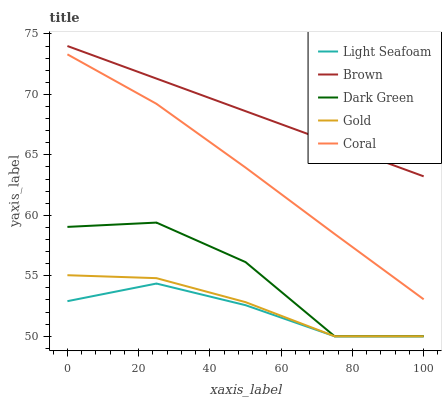Does Light Seafoam have the minimum area under the curve?
Answer yes or no. Yes. Does Brown have the maximum area under the curve?
Answer yes or no. Yes. Does Coral have the minimum area under the curve?
Answer yes or no. No. Does Coral have the maximum area under the curve?
Answer yes or no. No. Is Brown the smoothest?
Answer yes or no. Yes. Is Dark Green the roughest?
Answer yes or no. Yes. Is Coral the smoothest?
Answer yes or no. No. Is Coral the roughest?
Answer yes or no. No. Does Light Seafoam have the lowest value?
Answer yes or no. Yes. Does Coral have the lowest value?
Answer yes or no. No. Does Brown have the highest value?
Answer yes or no. Yes. Does Coral have the highest value?
Answer yes or no. No. Is Coral less than Brown?
Answer yes or no. Yes. Is Coral greater than Light Seafoam?
Answer yes or no. Yes. Does Dark Green intersect Gold?
Answer yes or no. Yes. Is Dark Green less than Gold?
Answer yes or no. No. Is Dark Green greater than Gold?
Answer yes or no. No. Does Coral intersect Brown?
Answer yes or no. No. 